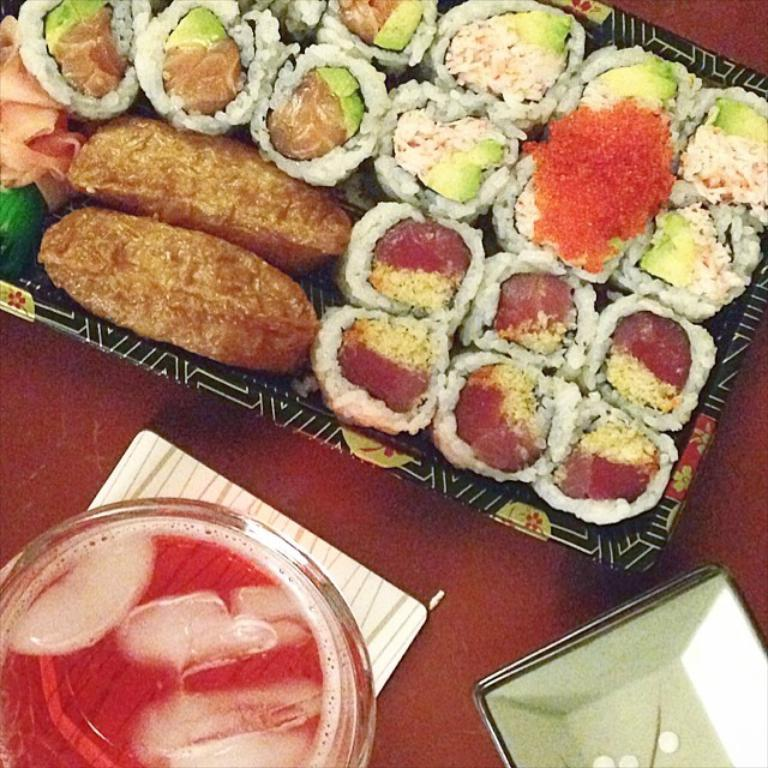What type of container is visible in the image? There is a bowl in the image. What other type of container is present in the image? There is a plate in the image. What is the third container-like object in the image? There is a tray in the image. What is on the tray? There is food present on the tray. Where are these objects located? The objects (bowl, plate, and tray) appear to be on a table. What type of bread is being attacked by a wren in the image? There is no bread or wren present in the image. 